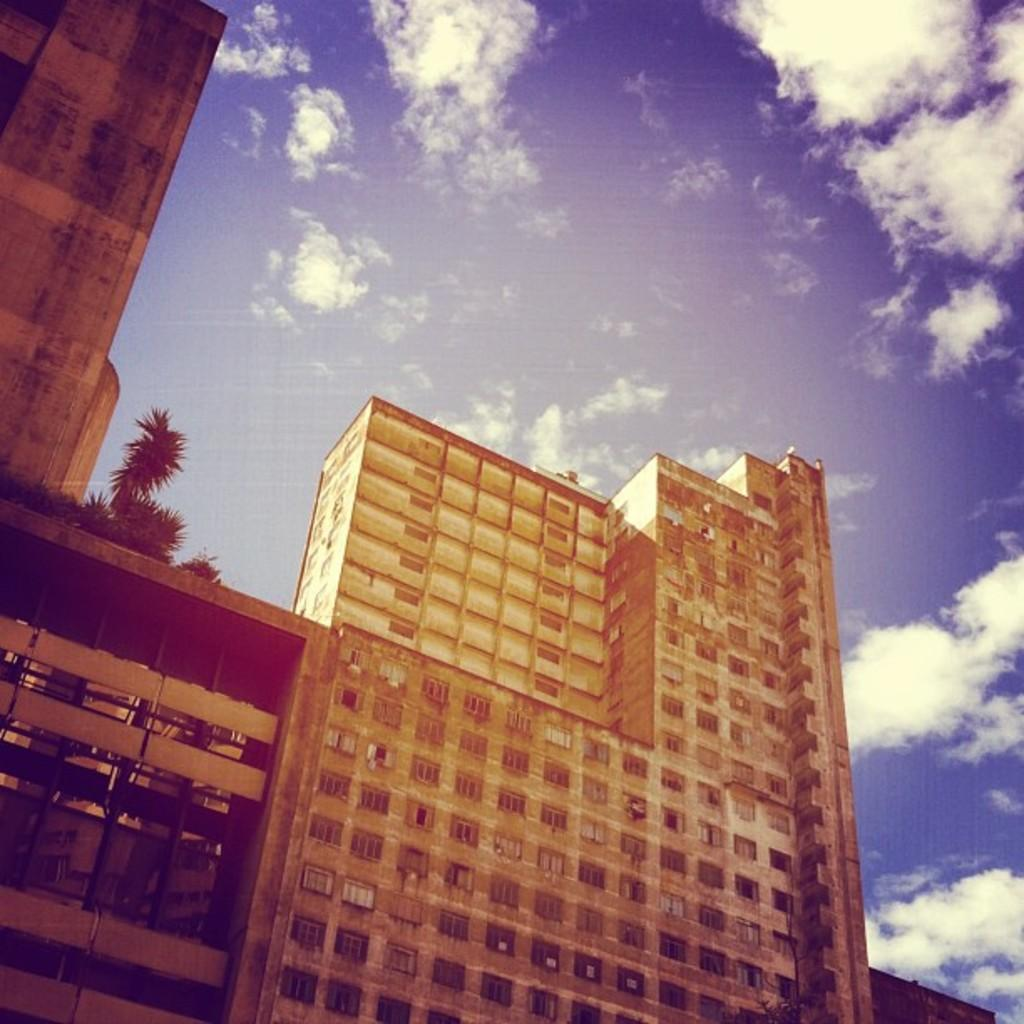What is the main subject of the image? There is a skyscraper in the center of the image. Can you describe the skyscraper in the image? The skyscraper is the main subject and is located in the center of the image. What type of structure is the skyscraper? The skyscraper is a tall building, typically used for commercial or residential purposes. How does the skyscraper show respect to the neighboring buildings in the image? The image does not depict any interaction between the skyscraper and neighboring buildings, so it cannot be determined if the skyscraper is showing respect. 